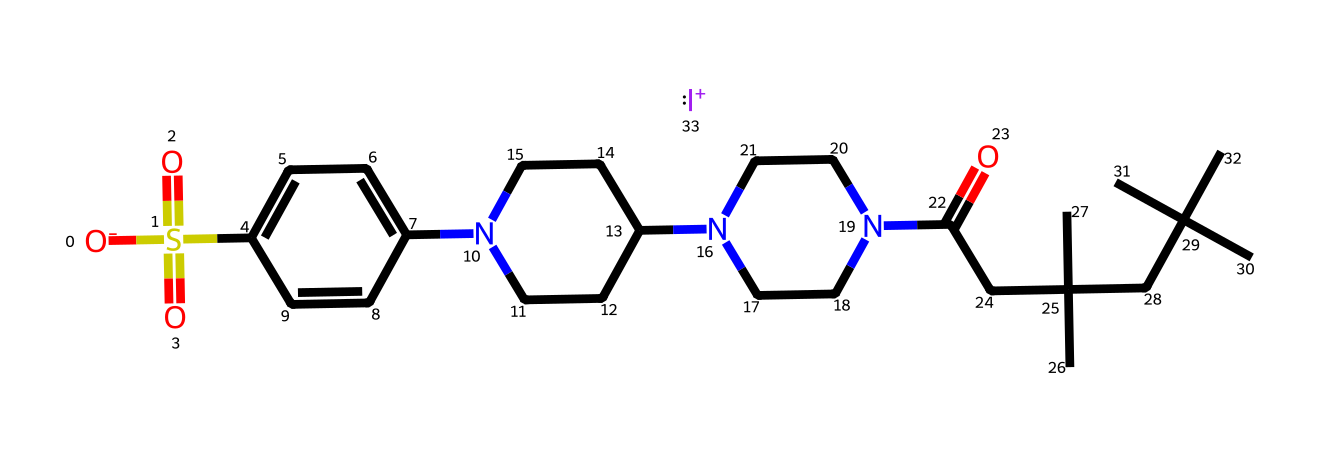What is the central halogen in this molecule? The molecule includes a positively charged iodine ion, which can be identified by the notation [I+] in the SMILES representation. Iodine is a halogen.
Answer: iodine How many carbon atoms are present in this chemical? By examining the structure in the SMILES notation, we can count a total of 22 carbon (C) atoms in the entire compound based on the number of 'C' notations while considering the branching and cyclic configurations as evident from the rings and chains.
Answer: 22 What functional group is indicated by the "N" in the SMILES notation? The presence of the nitrogen atoms (N) in the structure indicates that there are amine functional groups, which are commonly found in compounds exhibiting antibacterial properties.
Answer: amine Which part of the molecule contributes to its antibacterial properties? The iodine ion ([I+]) is a recognized antiseptic and is what makes this compound effective against bacteria, as iodine is widely known for its disinfecting action.
Answer: iodine How many nitrogen atoms are found in the molecule? By analyzing the SMILES structure and counting the 'N' notations, it can be noted that there are 4 nitrogen atoms present in the chemical structure.
Answer: 4 What class of antiseptics does this compound belong to? This molecule can be classified as an iodine-based antiseptic due to the presence of the iodine ion ([I+]), which is characteristic of this particular class of antiseptics.
Answer: iodine-based antiseptic Is this compound primarily hydrophilic or hydrophobic? Due to the presence of many carbon chains and the large hydrocarbon structure alongside the iodine, the compound is primarily hydrophobic overall, even though it may have some hydrophilic groups from the amines.
Answer: hydrophobic 